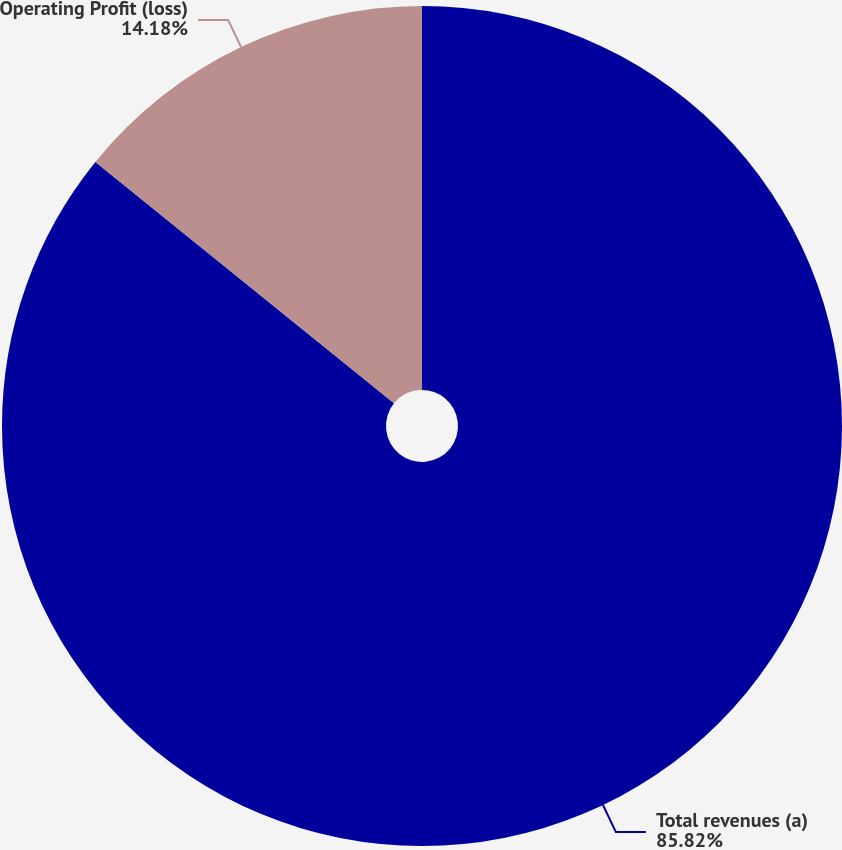Convert chart to OTSL. <chart><loc_0><loc_0><loc_500><loc_500><pie_chart><fcel>Total revenues (a)<fcel>Operating Profit (loss)<nl><fcel>85.82%<fcel>14.18%<nl></chart> 